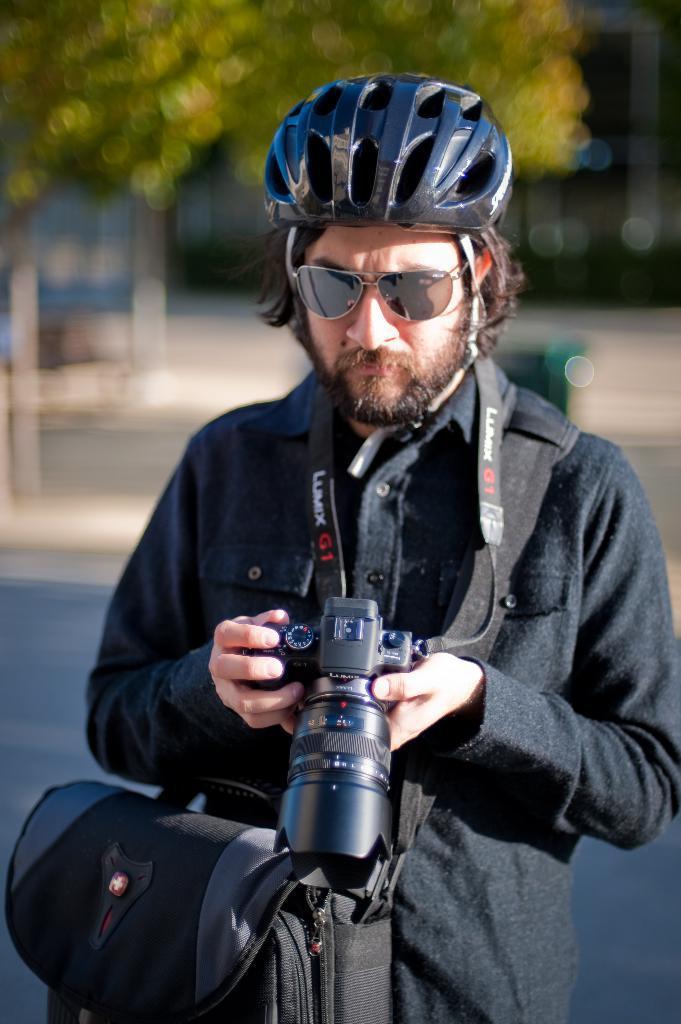Describe this image in one or two sentences. In this image i can see a man wearing a black shirt and wearing a spectacles and holding a camera and carrying a bag standing on the road. back side of him there are some trees visible. 